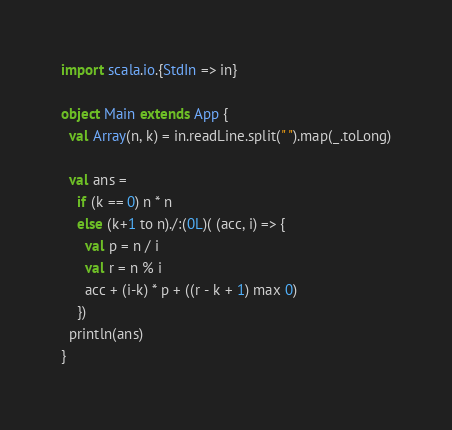<code> <loc_0><loc_0><loc_500><loc_500><_Scala_>import scala.io.{StdIn => in}

object Main extends App {
  val Array(n, k) = in.readLine.split(" ").map(_.toLong)

  val ans = 
    if (k == 0) n * n
    else (k+1 to n)./:(0L)( (acc, i) => {
      val p = n / i
      val r = n % i
      acc + (i-k) * p + ((r - k + 1) max 0)
    })
  println(ans)
}</code> 